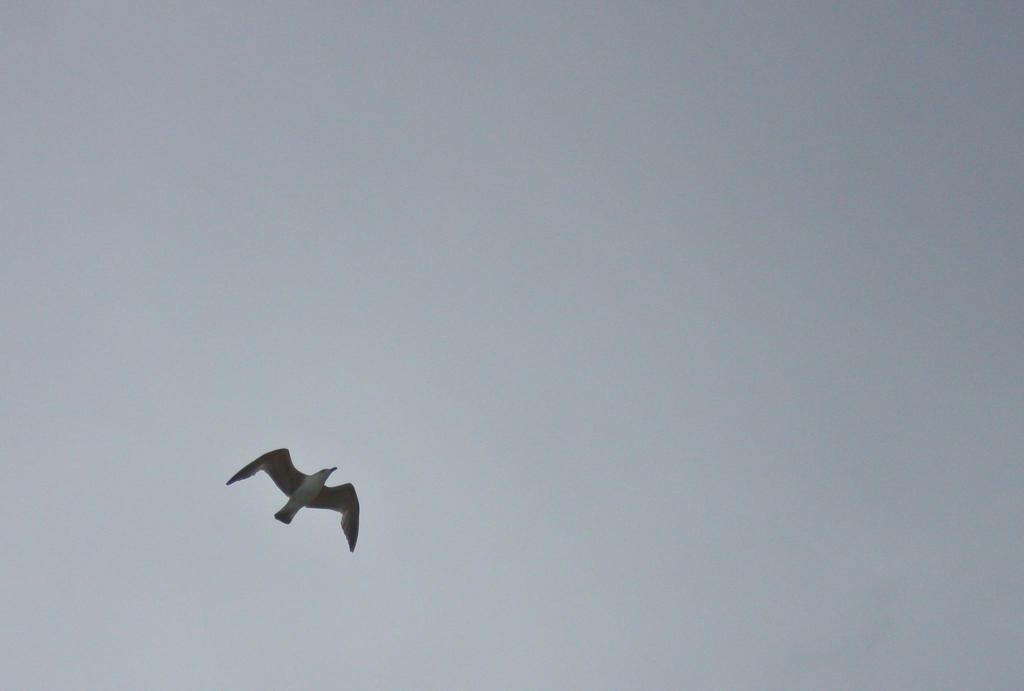What is the main subject of the image? The main subject of the image is a bird flying. What can be seen in the background of the image? The sky is visible in the background of the image. What type of soap is the bird using to clean itself in the image? There is no soap present in the image, and the bird is not shown cleaning itself. 